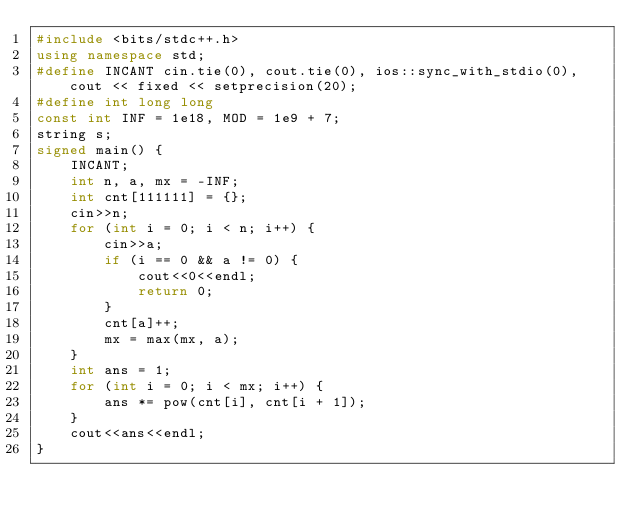Convert code to text. <code><loc_0><loc_0><loc_500><loc_500><_C++_>#include <bits/stdc++.h>
using namespace std;
#define INCANT cin.tie(0), cout.tie(0), ios::sync_with_stdio(0), cout << fixed << setprecision(20);
#define int long long
const int INF = 1e18, MOD = 1e9 + 7;
string s;
signed main() {
    INCANT;
    int n, a, mx = -INF;
    int cnt[111111] = {};
    cin>>n;
    for (int i = 0; i < n; i++) {
        cin>>a;
        if (i == 0 && a != 0) {
            cout<<0<<endl;
            return 0;
        }
        cnt[a]++;
        mx = max(mx, a);
    }
    int ans = 1;
    for (int i = 0; i < mx; i++) {
        ans *= pow(cnt[i], cnt[i + 1]);
    }
    cout<<ans<<endl;
}
</code> 